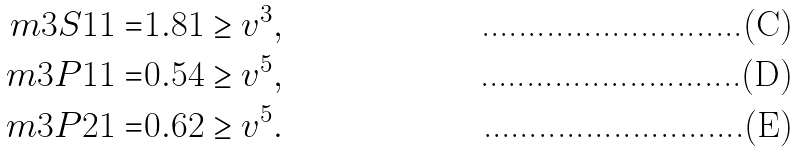<formula> <loc_0><loc_0><loc_500><loc_500>\ m { 3 } { S } { 1 } { 1 } = & 1 . 8 1 \geq v ^ { 3 } , \\ \ m { 3 } { P } { 1 } { 1 } = & 0 . 5 4 \geq v ^ { 5 } , \\ \ m { 3 } { P } { 2 } { 1 } = & 0 . 6 2 \geq v ^ { 5 } .</formula> 